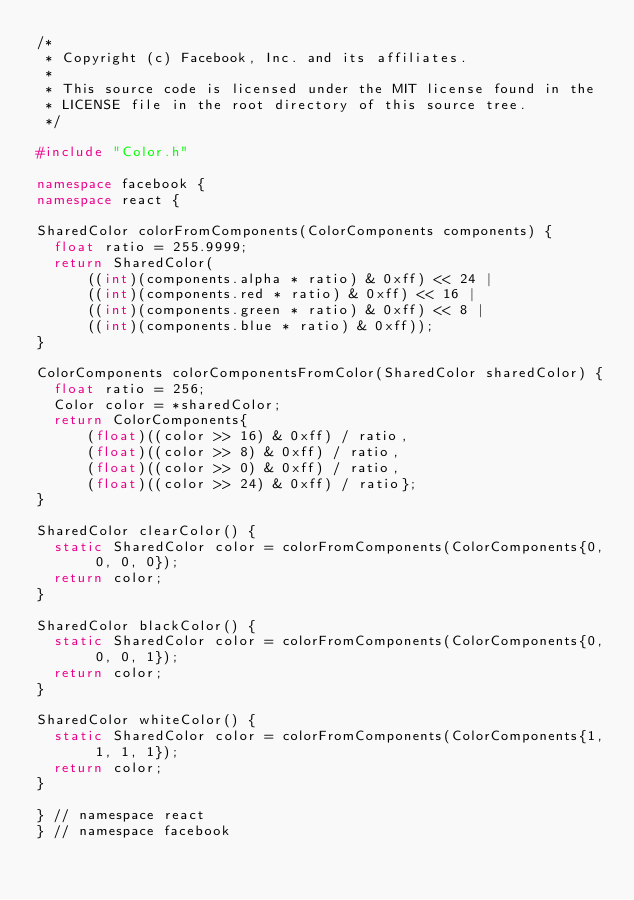<code> <loc_0><loc_0><loc_500><loc_500><_C++_>/*
 * Copyright (c) Facebook, Inc. and its affiliates.
 *
 * This source code is licensed under the MIT license found in the
 * LICENSE file in the root directory of this source tree.
 */

#include "Color.h"

namespace facebook {
namespace react {

SharedColor colorFromComponents(ColorComponents components) {
  float ratio = 255.9999;
  return SharedColor(
      ((int)(components.alpha * ratio) & 0xff) << 24 |
      ((int)(components.red * ratio) & 0xff) << 16 |
      ((int)(components.green * ratio) & 0xff) << 8 |
      ((int)(components.blue * ratio) & 0xff));
}

ColorComponents colorComponentsFromColor(SharedColor sharedColor) {
  float ratio = 256;
  Color color = *sharedColor;
  return ColorComponents{
      (float)((color >> 16) & 0xff) / ratio,
      (float)((color >> 8) & 0xff) / ratio,
      (float)((color >> 0) & 0xff) / ratio,
      (float)((color >> 24) & 0xff) / ratio};
}

SharedColor clearColor() {
  static SharedColor color = colorFromComponents(ColorComponents{0, 0, 0, 0});
  return color;
}

SharedColor blackColor() {
  static SharedColor color = colorFromComponents(ColorComponents{0, 0, 0, 1});
  return color;
}

SharedColor whiteColor() {
  static SharedColor color = colorFromComponents(ColorComponents{1, 1, 1, 1});
  return color;
}

} // namespace react
} // namespace facebook
</code> 